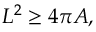Convert formula to latex. <formula><loc_0><loc_0><loc_500><loc_500>L ^ { 2 } \geq 4 \pi A ,</formula> 